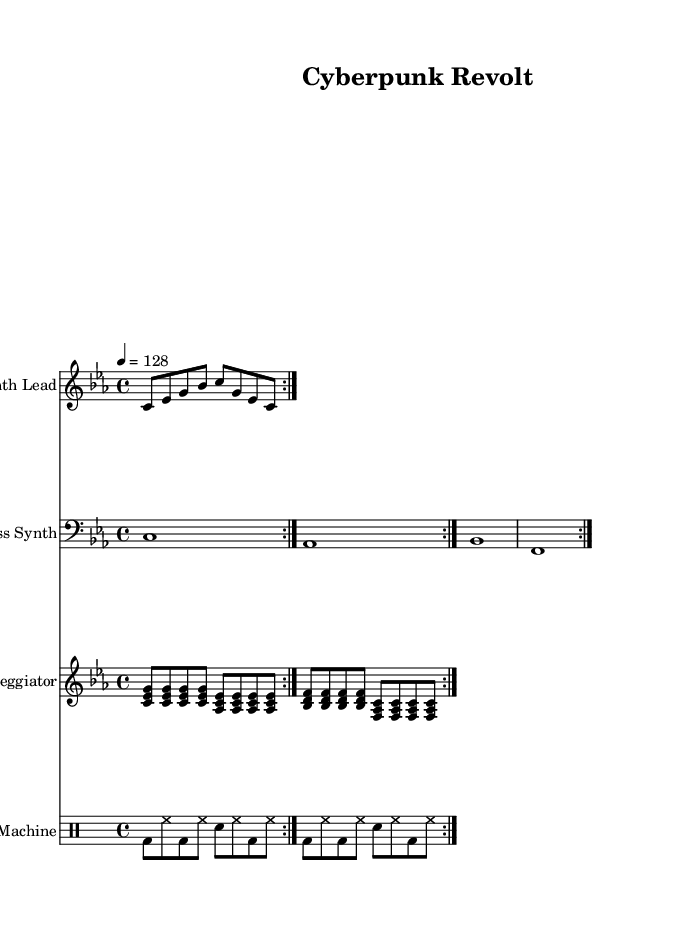What is the key signature of this music? The key signature is indicated at the beginning of the score, which shows 3 flat signs, representing the key of C minor.
Answer: C minor What is the time signature of this music? The time signature appears at the start of the musical staff and indicates a 4/4 time, meaning there are four beats per measure, and the quarter note gets one beat.
Answer: 4/4 What is the tempo marking for this piece? The tempo marking is also found at the beginning of the score and indicates a tempo of 128 beats per minute, meaning this piece is played relatively fast.
Answer: 128 How many measures does the synth lead part repeat? The repeat sign in the synth lead section indicates that this part is played twice, making it two measures in total that are repeated during the performance.
Answer: 2 What instruments are featured in this score? By examining the different staves, it is clear that the score includes a Synth Lead, Bass Synth, Arpeggiator, and a Drum Machine, which are all indicated at the beginning of their respective staves.
Answer: Synth Lead, Bass Synth, Arpeggiator, Drum Machine What type of musical motifs are prominent in the arpeggiator section? The arpeggiator section features rapid repeated notes grouped in triads and seventh chords, indicative of the electronic music style, typically forming a harmonic and rhythmic background.
Answer: Triads and seventh chords 